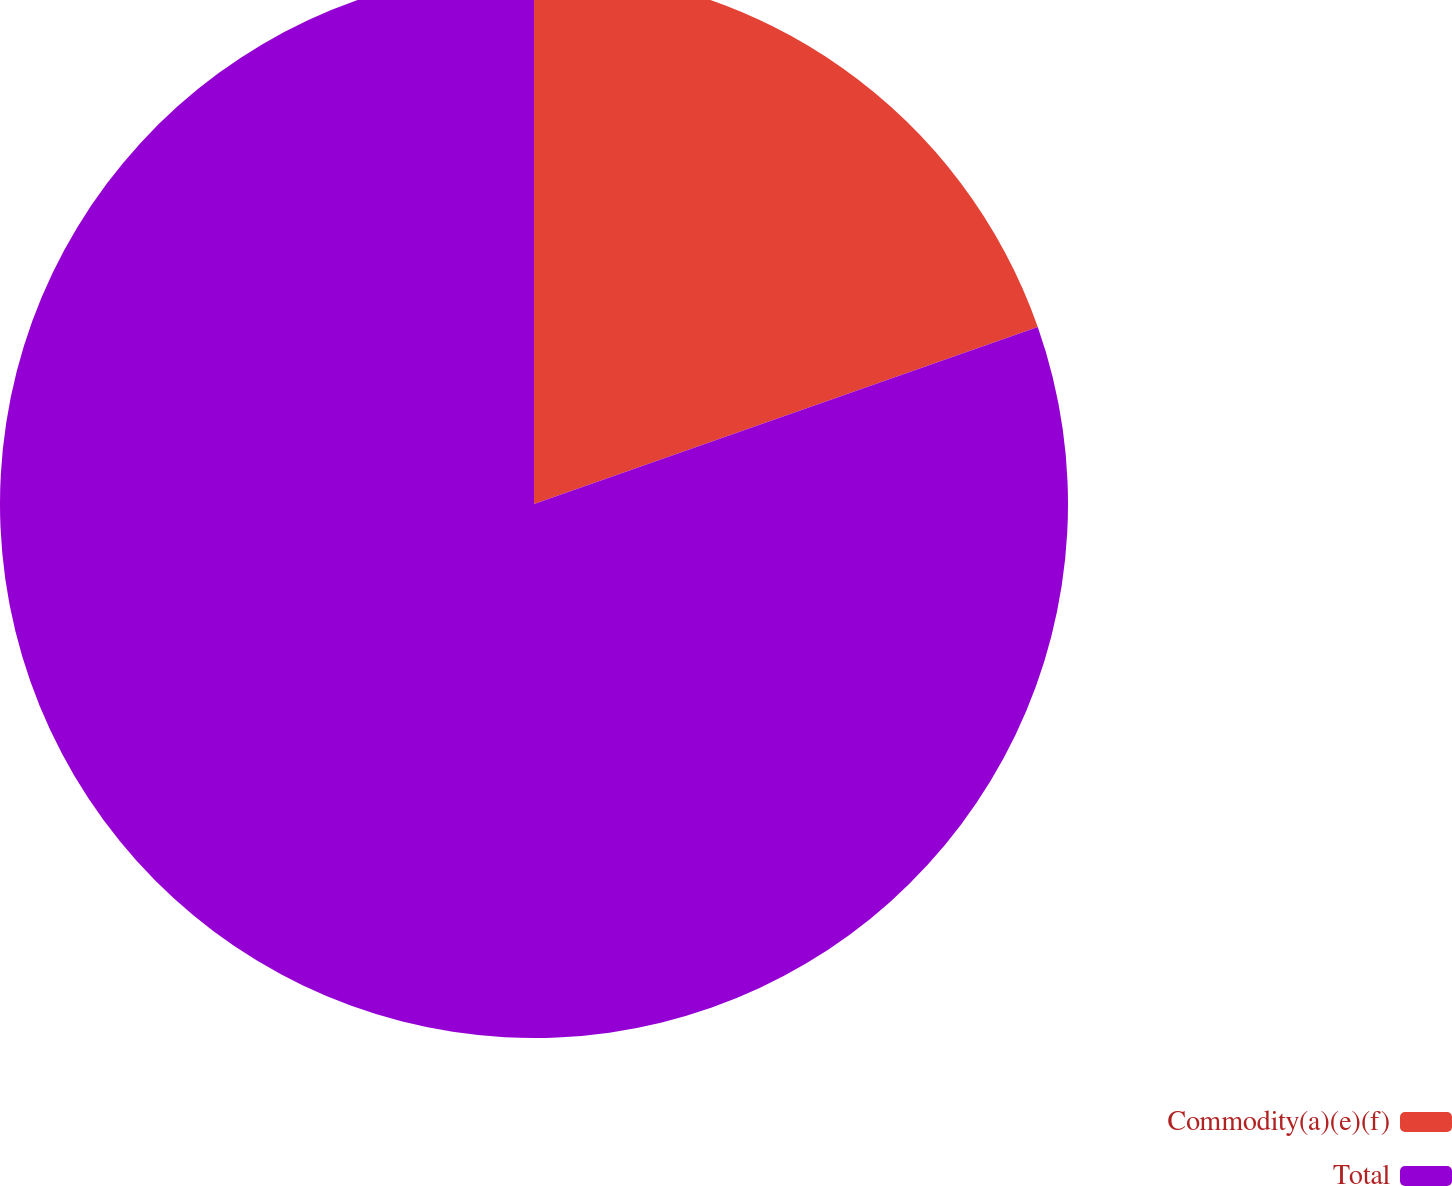Convert chart. <chart><loc_0><loc_0><loc_500><loc_500><pie_chart><fcel>Commodity(a)(e)(f)<fcel>Total<nl><fcel>19.62%<fcel>80.38%<nl></chart> 